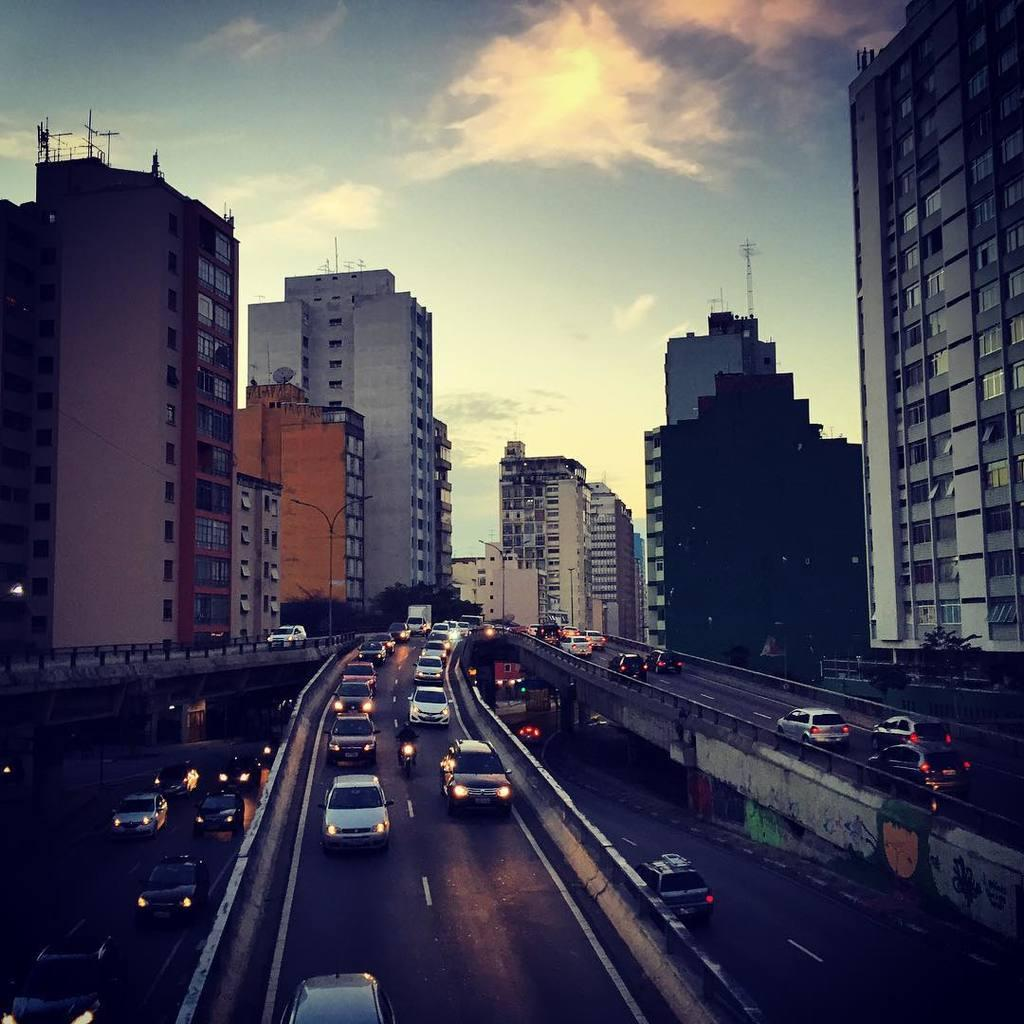What can be seen at the bottom of the image? There are vehicles on the road at the bottom of the image. What is located in the middle of the image? There are buildings in the middle of the image. What is visible at the top of the image? The sky is visible at the top of the image. What can be observed in the sky? There are clouds in the sky. Where is the wren perched in the image? There is no wren present in the image. What force is acting on the buildings in the image? There is no indication of any force acting on the buildings in the image. 